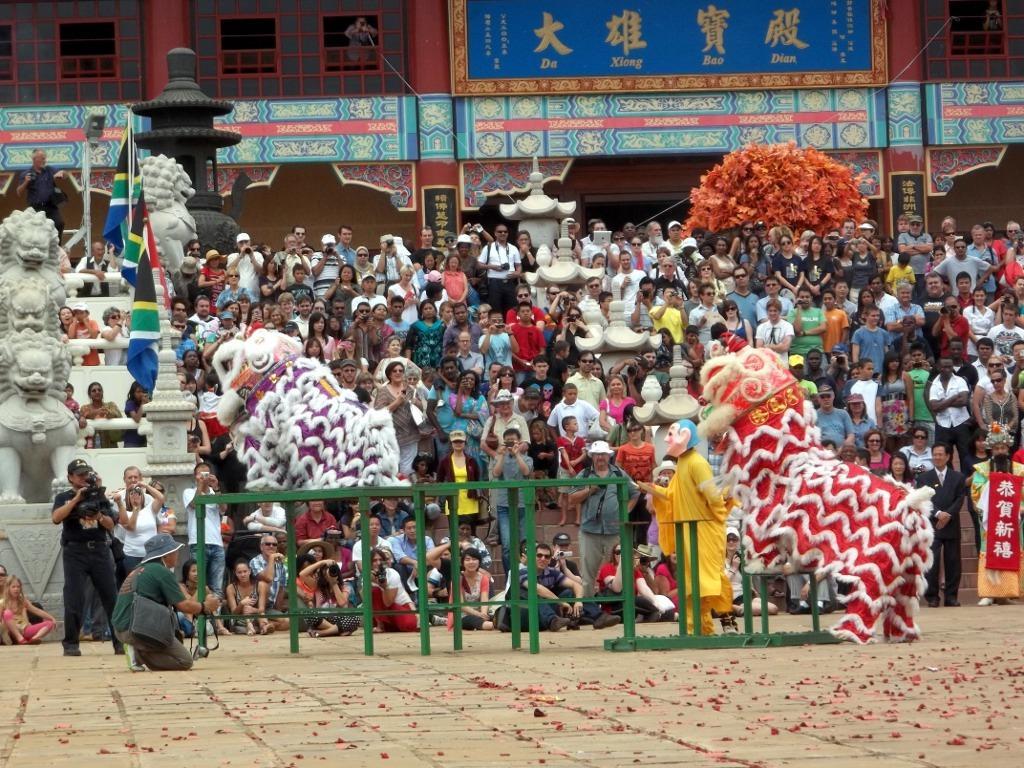In one or two sentences, can you explain what this image depicts? This image is taken outdoors. At the bottom of the image there is a floor. In the background there is a building. There are a few boards with text on them. There is a tree. In the middle of the image there are many people. A few are standing and a few are sitting. There are many sculptures. There are a few flags. There are a few toys and there are a few iron bars. 